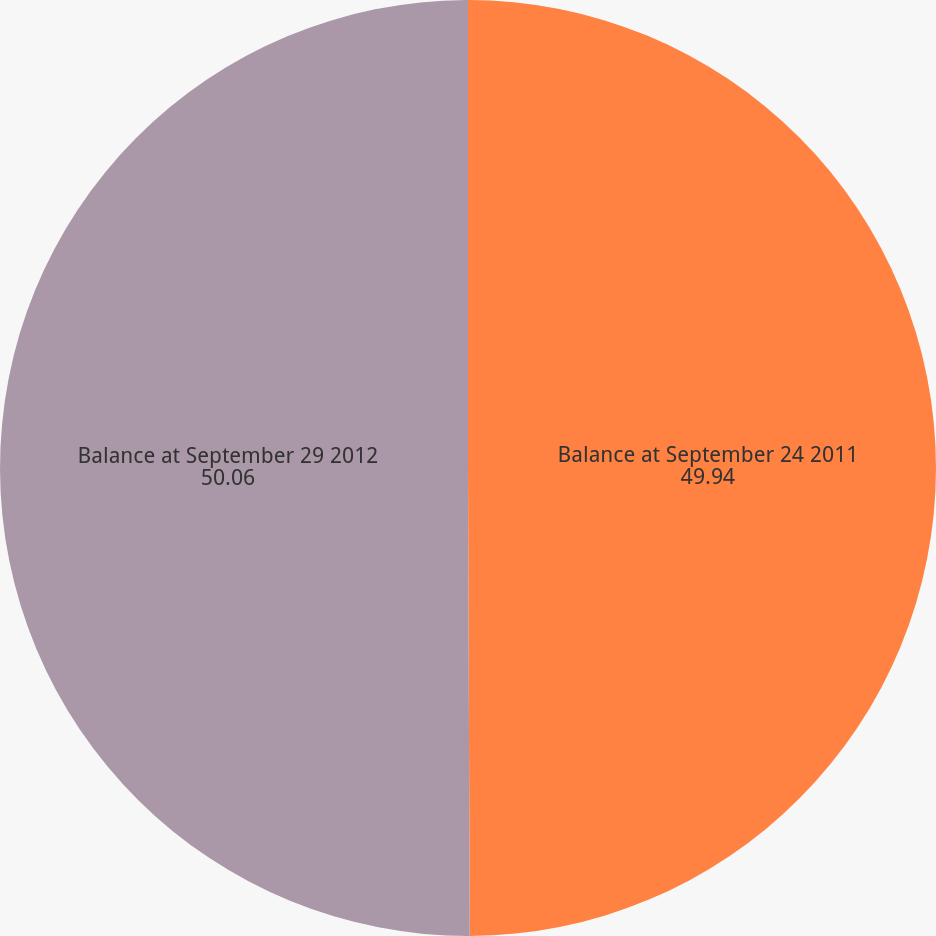Convert chart. <chart><loc_0><loc_0><loc_500><loc_500><pie_chart><fcel>Balance at September 24 2011<fcel>Balance at September 29 2012<nl><fcel>49.94%<fcel>50.06%<nl></chart> 